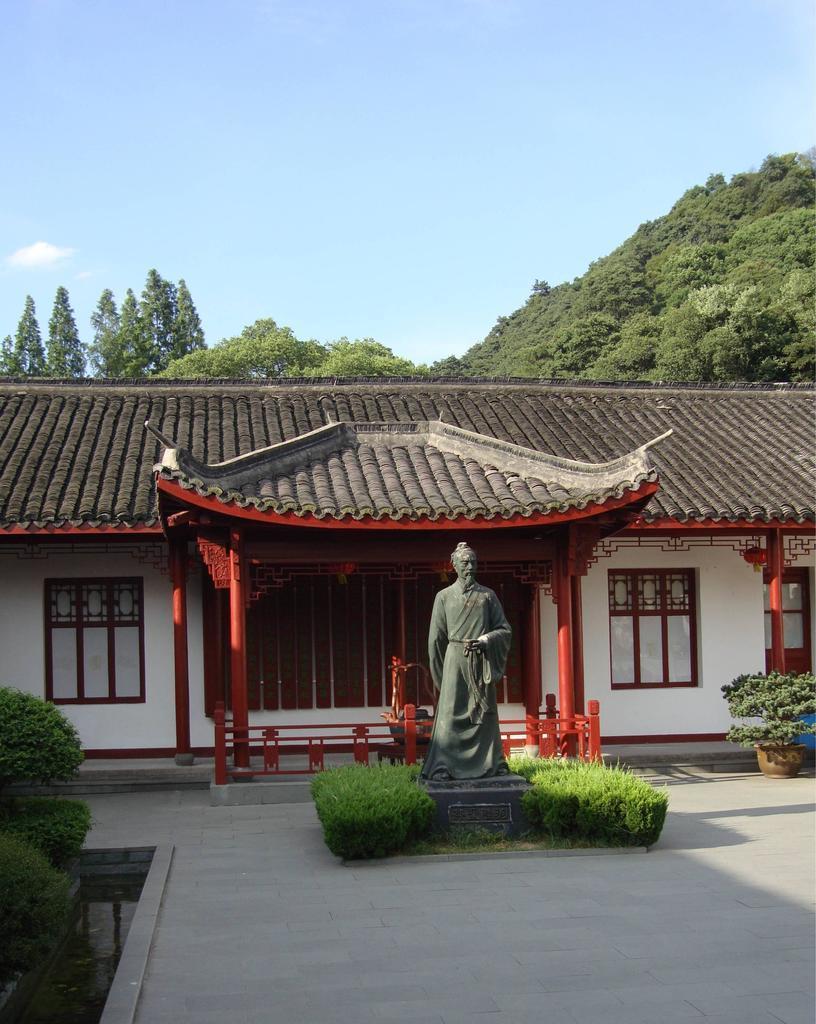Please provide a concise description of this image. In this image there is a house. In front of the house there is a statue. On the left side there are plants. In the background there are trees. On the right side there are plant pots on the floor. There is grass around the statue. 